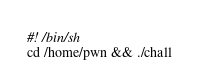Convert code to text. <code><loc_0><loc_0><loc_500><loc_500><_Bash_>#! /bin/sh
cd /home/pwn && ./chall
</code> 